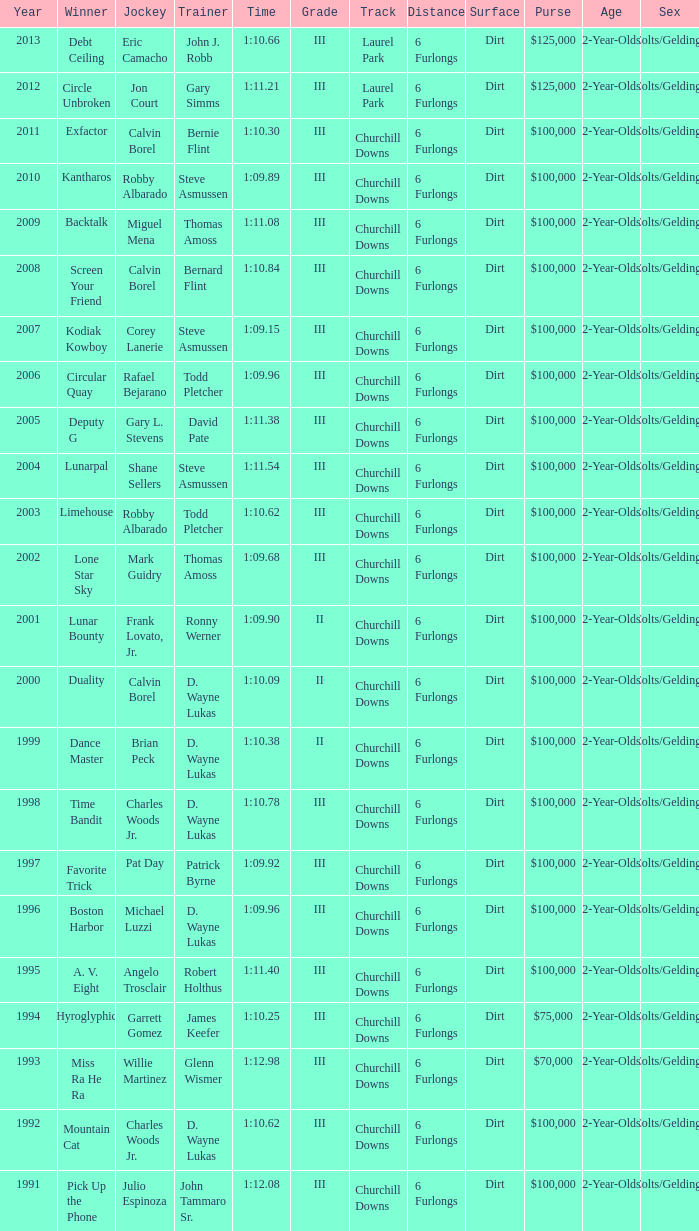Write the full table. {'header': ['Year', 'Winner', 'Jockey', 'Trainer', 'Time', 'Grade', 'Track', 'Distance', 'Surface', 'Purse', 'Age', 'Sex'], 'rows': [['2013', 'Debt Ceiling', 'Eric Camacho', 'John J. Robb', '1:10.66', 'III', 'Laurel Park', '6 Furlongs', 'Dirt', '$125,000', '2-Year-Olds', 'Colts/Geldings'], ['2012', 'Circle Unbroken', 'Jon Court', 'Gary Simms', '1:11.21', 'III', 'Laurel Park', '6 Furlongs', 'Dirt', '$125,000', '2-Year-Olds', 'Colts/Geldings'], ['2011', 'Exfactor', 'Calvin Borel', 'Bernie Flint', '1:10.30', 'III', 'Churchill Downs', '6 Furlongs', 'Dirt', '$100,000', '2-Year-Olds', 'Colts/Geldings'], ['2010', 'Kantharos', 'Robby Albarado', 'Steve Asmussen', '1:09.89', 'III', 'Churchill Downs', '6 Furlongs', 'Dirt', '$100,000', '2-Year-Olds', 'Colts/Geldings'], ['2009', 'Backtalk', 'Miguel Mena', 'Thomas Amoss', '1:11.08', 'III', 'Churchill Downs', '6 Furlongs', 'Dirt', '$100,000', '2-Year-Olds', 'Colts/Geldings'], ['2008', 'Screen Your Friend', 'Calvin Borel', 'Bernard Flint', '1:10.84', 'III', 'Churchill Downs', '6 Furlongs', 'Dirt', '$100,000', '2-Year-Olds', 'Colts/Geldings'], ['2007', 'Kodiak Kowboy', 'Corey Lanerie', 'Steve Asmussen', '1:09.15', 'III', 'Churchill Downs', '6 Furlongs', 'Dirt', '$100,000', '2-Year-Olds', 'Colts/Geldings'], ['2006', 'Circular Quay', 'Rafael Bejarano', 'Todd Pletcher', '1:09.96', 'III', 'Churchill Downs', '6 Furlongs', 'Dirt', '$100,000', '2-Year-Olds', 'Colts/Geldings'], ['2005', 'Deputy G', 'Gary L. Stevens', 'David Pate', '1:11.38', 'III', 'Churchill Downs', '6 Furlongs', 'Dirt', '$100,000', '2-Year-Olds', 'Colts/Geldings'], ['2004', 'Lunarpal', 'Shane Sellers', 'Steve Asmussen', '1:11.54', 'III', 'Churchill Downs', '6 Furlongs', 'Dirt', '$100,000', '2-Year-Olds', 'Colts/Geldings'], ['2003', 'Limehouse', 'Robby Albarado', 'Todd Pletcher', '1:10.62', 'III', 'Churchill Downs', '6 Furlongs', 'Dirt', '$100,000', '2-Year-Olds', 'Colts/Geldings'], ['2002', 'Lone Star Sky', 'Mark Guidry', 'Thomas Amoss', '1:09.68', 'III', 'Churchill Downs', '6 Furlongs', 'Dirt', '$100,000', '2-Year-Olds', 'Colts/Geldings'], ['2001', 'Lunar Bounty', 'Frank Lovato, Jr.', 'Ronny Werner', '1:09.90', 'II', 'Churchill Downs', '6 Furlongs', 'Dirt', '$100,000', '2-Year-Olds', 'Colts/Geldings'], ['2000', 'Duality', 'Calvin Borel', 'D. Wayne Lukas', '1:10.09', 'II', 'Churchill Downs', '6 Furlongs', 'Dirt', '$100,000', '2-Year-Olds', 'Colts/Geldings'], ['1999', 'Dance Master', 'Brian Peck', 'D. Wayne Lukas', '1:10.38', 'II', 'Churchill Downs', '6 Furlongs', 'Dirt', '$100,000', '2-Year-Olds', 'Colts/Geldings'], ['1998', 'Time Bandit', 'Charles Woods Jr.', 'D. Wayne Lukas', '1:10.78', 'III', 'Churchill Downs', '6 Furlongs', 'Dirt', '$100,000', '2-Year-Olds', 'Colts/Geldings'], ['1997', 'Favorite Trick', 'Pat Day', 'Patrick Byrne', '1:09.92', 'III', 'Churchill Downs', '6 Furlongs', 'Dirt', '$100,000', '2-Year-Olds', 'Colts/Geldings'], ['1996', 'Boston Harbor', 'Michael Luzzi', 'D. Wayne Lukas', '1:09.96', 'III', 'Churchill Downs', '6 Furlongs', 'Dirt', '$100,000', '2-Year-Olds', 'Colts/Geldings'], ['1995', 'A. V. Eight', 'Angelo Trosclair', 'Robert Holthus', '1:11.40', 'III', 'Churchill Downs', '6 Furlongs', 'Dirt', '$100,000', '2-Year-Olds', 'Colts/Geldings'], ['1994', 'Hyroglyphic', 'Garrett Gomez', 'James Keefer', '1:10.25', 'III', 'Churchill Downs', '6 Furlongs', 'Dirt', '$75,000', '2-Year-Olds', 'Colts/Geldings'], ['1993', 'Miss Ra He Ra', 'Willie Martinez', 'Glenn Wismer', '1:12.98', 'III', 'Churchill Downs', '6 Furlongs', 'Dirt', '$70,000', '2-Year-Olds', 'Colts/Geldings'], ['1992', 'Mountain Cat', 'Charles Woods Jr.', 'D. Wayne Lukas', '1:10.62', 'III', 'Churchill Downs', '6 Furlongs', 'Dirt', '$100,000', '2-Year-Olds', 'Colts/Geldings'], ['1991', 'Pick Up the Phone', 'Julio Espinoza', 'John Tammaro Sr.', '1:12.08', 'III', 'Churchill Downs', '6 Furlongs', 'Dirt', '$100,000', '2-Year-Olds', 'Colts/Geldings']]} Who won under Gary Simms? Circle Unbroken. 